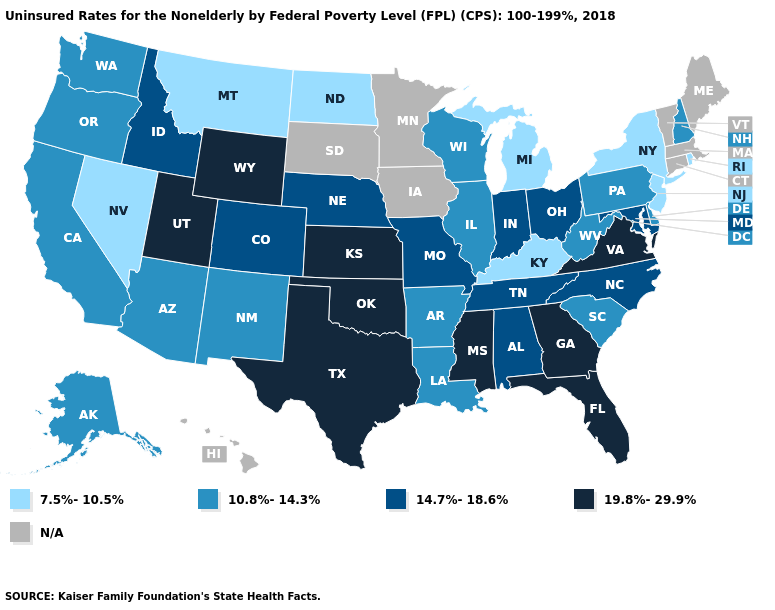What is the highest value in the MidWest ?
Give a very brief answer. 19.8%-29.9%. Name the states that have a value in the range 19.8%-29.9%?
Answer briefly. Florida, Georgia, Kansas, Mississippi, Oklahoma, Texas, Utah, Virginia, Wyoming. What is the lowest value in the USA?
Concise answer only. 7.5%-10.5%. Does the map have missing data?
Give a very brief answer. Yes. Name the states that have a value in the range 7.5%-10.5%?
Write a very short answer. Kentucky, Michigan, Montana, Nevada, New Jersey, New York, North Dakota, Rhode Island. What is the highest value in states that border Utah?
Give a very brief answer. 19.8%-29.9%. What is the value of Florida?
Quick response, please. 19.8%-29.9%. What is the value of Maine?
Write a very short answer. N/A. What is the lowest value in the USA?
Answer briefly. 7.5%-10.5%. Name the states that have a value in the range N/A?
Keep it brief. Connecticut, Hawaii, Iowa, Maine, Massachusetts, Minnesota, South Dakota, Vermont. Name the states that have a value in the range N/A?
Keep it brief. Connecticut, Hawaii, Iowa, Maine, Massachusetts, Minnesota, South Dakota, Vermont. Does New York have the lowest value in the Northeast?
Short answer required. Yes. 